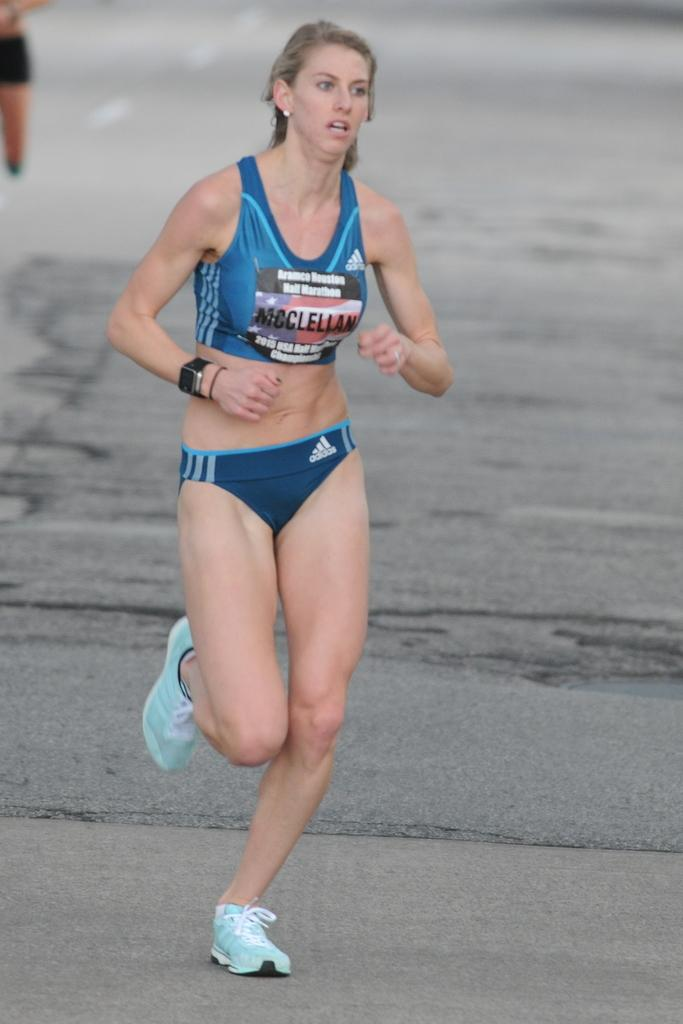<image>
Present a compact description of the photo's key features. A woman wears a participant bib that reads Mcclellan. 